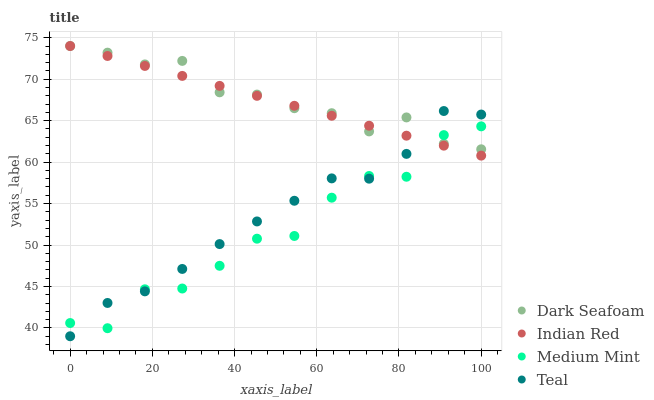Does Medium Mint have the minimum area under the curve?
Answer yes or no. Yes. Does Dark Seafoam have the maximum area under the curve?
Answer yes or no. Yes. Does Teal have the minimum area under the curve?
Answer yes or no. No. Does Teal have the maximum area under the curve?
Answer yes or no. No. Is Indian Red the smoothest?
Answer yes or no. Yes. Is Medium Mint the roughest?
Answer yes or no. Yes. Is Dark Seafoam the smoothest?
Answer yes or no. No. Is Dark Seafoam the roughest?
Answer yes or no. No. Does Teal have the lowest value?
Answer yes or no. Yes. Does Dark Seafoam have the lowest value?
Answer yes or no. No. Does Indian Red have the highest value?
Answer yes or no. Yes. Does Teal have the highest value?
Answer yes or no. No. Does Medium Mint intersect Indian Red?
Answer yes or no. Yes. Is Medium Mint less than Indian Red?
Answer yes or no. No. Is Medium Mint greater than Indian Red?
Answer yes or no. No. 